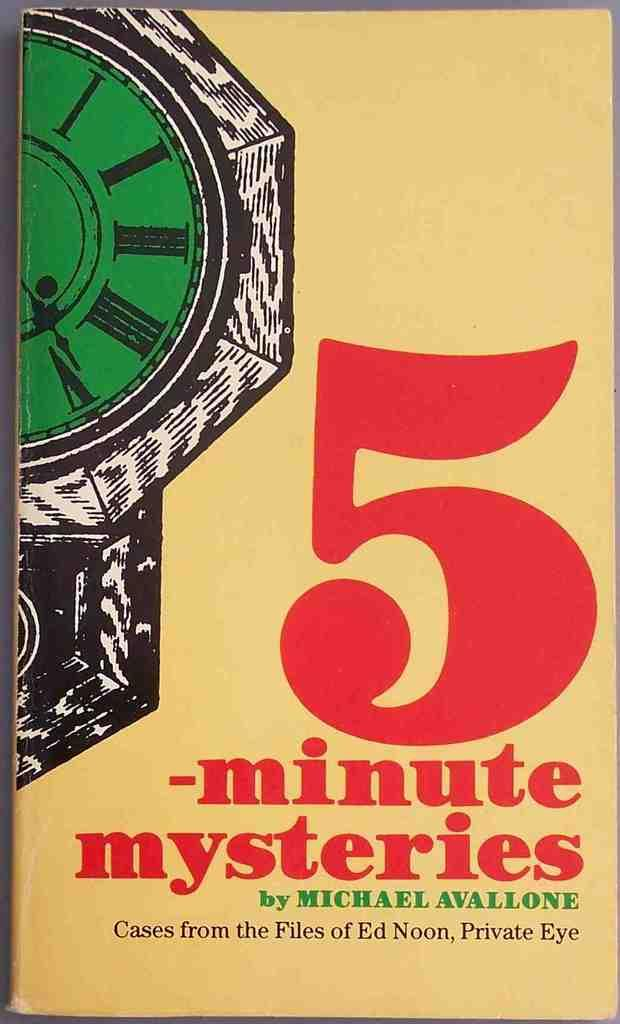<image>
Provide a brief description of the given image. A book titled 5 -minute mysteries by Michael Avallone sits on a table 